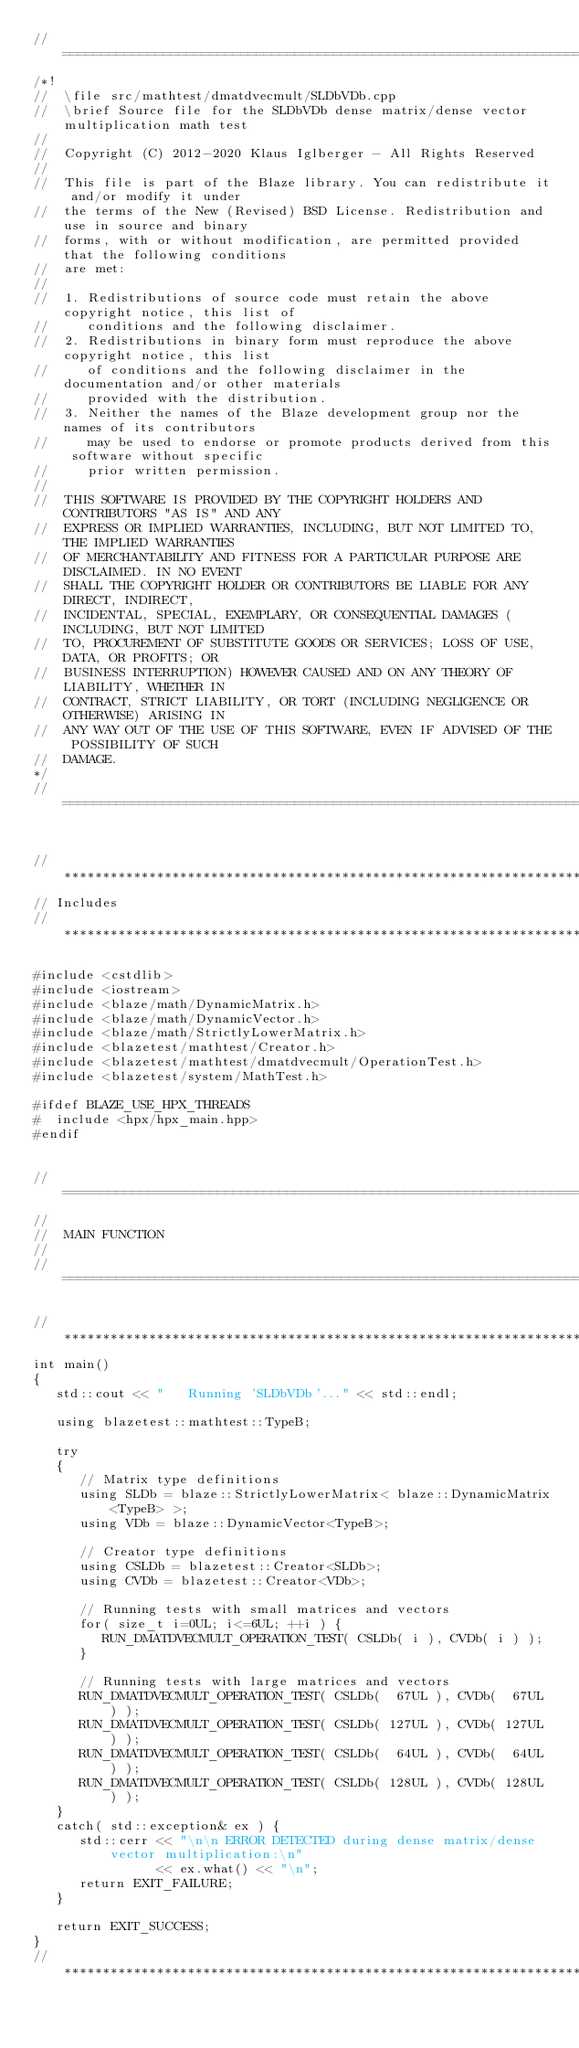Convert code to text. <code><loc_0><loc_0><loc_500><loc_500><_C++_>//=================================================================================================
/*!
//  \file src/mathtest/dmatdvecmult/SLDbVDb.cpp
//  \brief Source file for the SLDbVDb dense matrix/dense vector multiplication math test
//
//  Copyright (C) 2012-2020 Klaus Iglberger - All Rights Reserved
//
//  This file is part of the Blaze library. You can redistribute it and/or modify it under
//  the terms of the New (Revised) BSD License. Redistribution and use in source and binary
//  forms, with or without modification, are permitted provided that the following conditions
//  are met:
//
//  1. Redistributions of source code must retain the above copyright notice, this list of
//     conditions and the following disclaimer.
//  2. Redistributions in binary form must reproduce the above copyright notice, this list
//     of conditions and the following disclaimer in the documentation and/or other materials
//     provided with the distribution.
//  3. Neither the names of the Blaze development group nor the names of its contributors
//     may be used to endorse or promote products derived from this software without specific
//     prior written permission.
//
//  THIS SOFTWARE IS PROVIDED BY THE COPYRIGHT HOLDERS AND CONTRIBUTORS "AS IS" AND ANY
//  EXPRESS OR IMPLIED WARRANTIES, INCLUDING, BUT NOT LIMITED TO, THE IMPLIED WARRANTIES
//  OF MERCHANTABILITY AND FITNESS FOR A PARTICULAR PURPOSE ARE DISCLAIMED. IN NO EVENT
//  SHALL THE COPYRIGHT HOLDER OR CONTRIBUTORS BE LIABLE FOR ANY DIRECT, INDIRECT,
//  INCIDENTAL, SPECIAL, EXEMPLARY, OR CONSEQUENTIAL DAMAGES (INCLUDING, BUT NOT LIMITED
//  TO, PROCUREMENT OF SUBSTITUTE GOODS OR SERVICES; LOSS OF USE, DATA, OR PROFITS; OR
//  BUSINESS INTERRUPTION) HOWEVER CAUSED AND ON ANY THEORY OF LIABILITY, WHETHER IN
//  CONTRACT, STRICT LIABILITY, OR TORT (INCLUDING NEGLIGENCE OR OTHERWISE) ARISING IN
//  ANY WAY OUT OF THE USE OF THIS SOFTWARE, EVEN IF ADVISED OF THE POSSIBILITY OF SUCH
//  DAMAGE.
*/
//=================================================================================================


//*************************************************************************************************
// Includes
//*************************************************************************************************

#include <cstdlib>
#include <iostream>
#include <blaze/math/DynamicMatrix.h>
#include <blaze/math/DynamicVector.h>
#include <blaze/math/StrictlyLowerMatrix.h>
#include <blazetest/mathtest/Creator.h>
#include <blazetest/mathtest/dmatdvecmult/OperationTest.h>
#include <blazetest/system/MathTest.h>

#ifdef BLAZE_USE_HPX_THREADS
#  include <hpx/hpx_main.hpp>
#endif


//=================================================================================================
//
//  MAIN FUNCTION
//
//=================================================================================================

//*************************************************************************************************
int main()
{
   std::cout << "   Running 'SLDbVDb'..." << std::endl;

   using blazetest::mathtest::TypeB;

   try
   {
      // Matrix type definitions
      using SLDb = blaze::StrictlyLowerMatrix< blaze::DynamicMatrix<TypeB> >;
      using VDb = blaze::DynamicVector<TypeB>;

      // Creator type definitions
      using CSLDb = blazetest::Creator<SLDb>;
      using CVDb = blazetest::Creator<VDb>;

      // Running tests with small matrices and vectors
      for( size_t i=0UL; i<=6UL; ++i ) {
         RUN_DMATDVECMULT_OPERATION_TEST( CSLDb( i ), CVDb( i ) );
      }

      // Running tests with large matrices and vectors
      RUN_DMATDVECMULT_OPERATION_TEST( CSLDb(  67UL ), CVDb(  67UL ) );
      RUN_DMATDVECMULT_OPERATION_TEST( CSLDb( 127UL ), CVDb( 127UL ) );
      RUN_DMATDVECMULT_OPERATION_TEST( CSLDb(  64UL ), CVDb(  64UL ) );
      RUN_DMATDVECMULT_OPERATION_TEST( CSLDb( 128UL ), CVDb( 128UL ) );
   }
   catch( std::exception& ex ) {
      std::cerr << "\n\n ERROR DETECTED during dense matrix/dense vector multiplication:\n"
                << ex.what() << "\n";
      return EXIT_FAILURE;
   }

   return EXIT_SUCCESS;
}
//*************************************************************************************************
</code> 